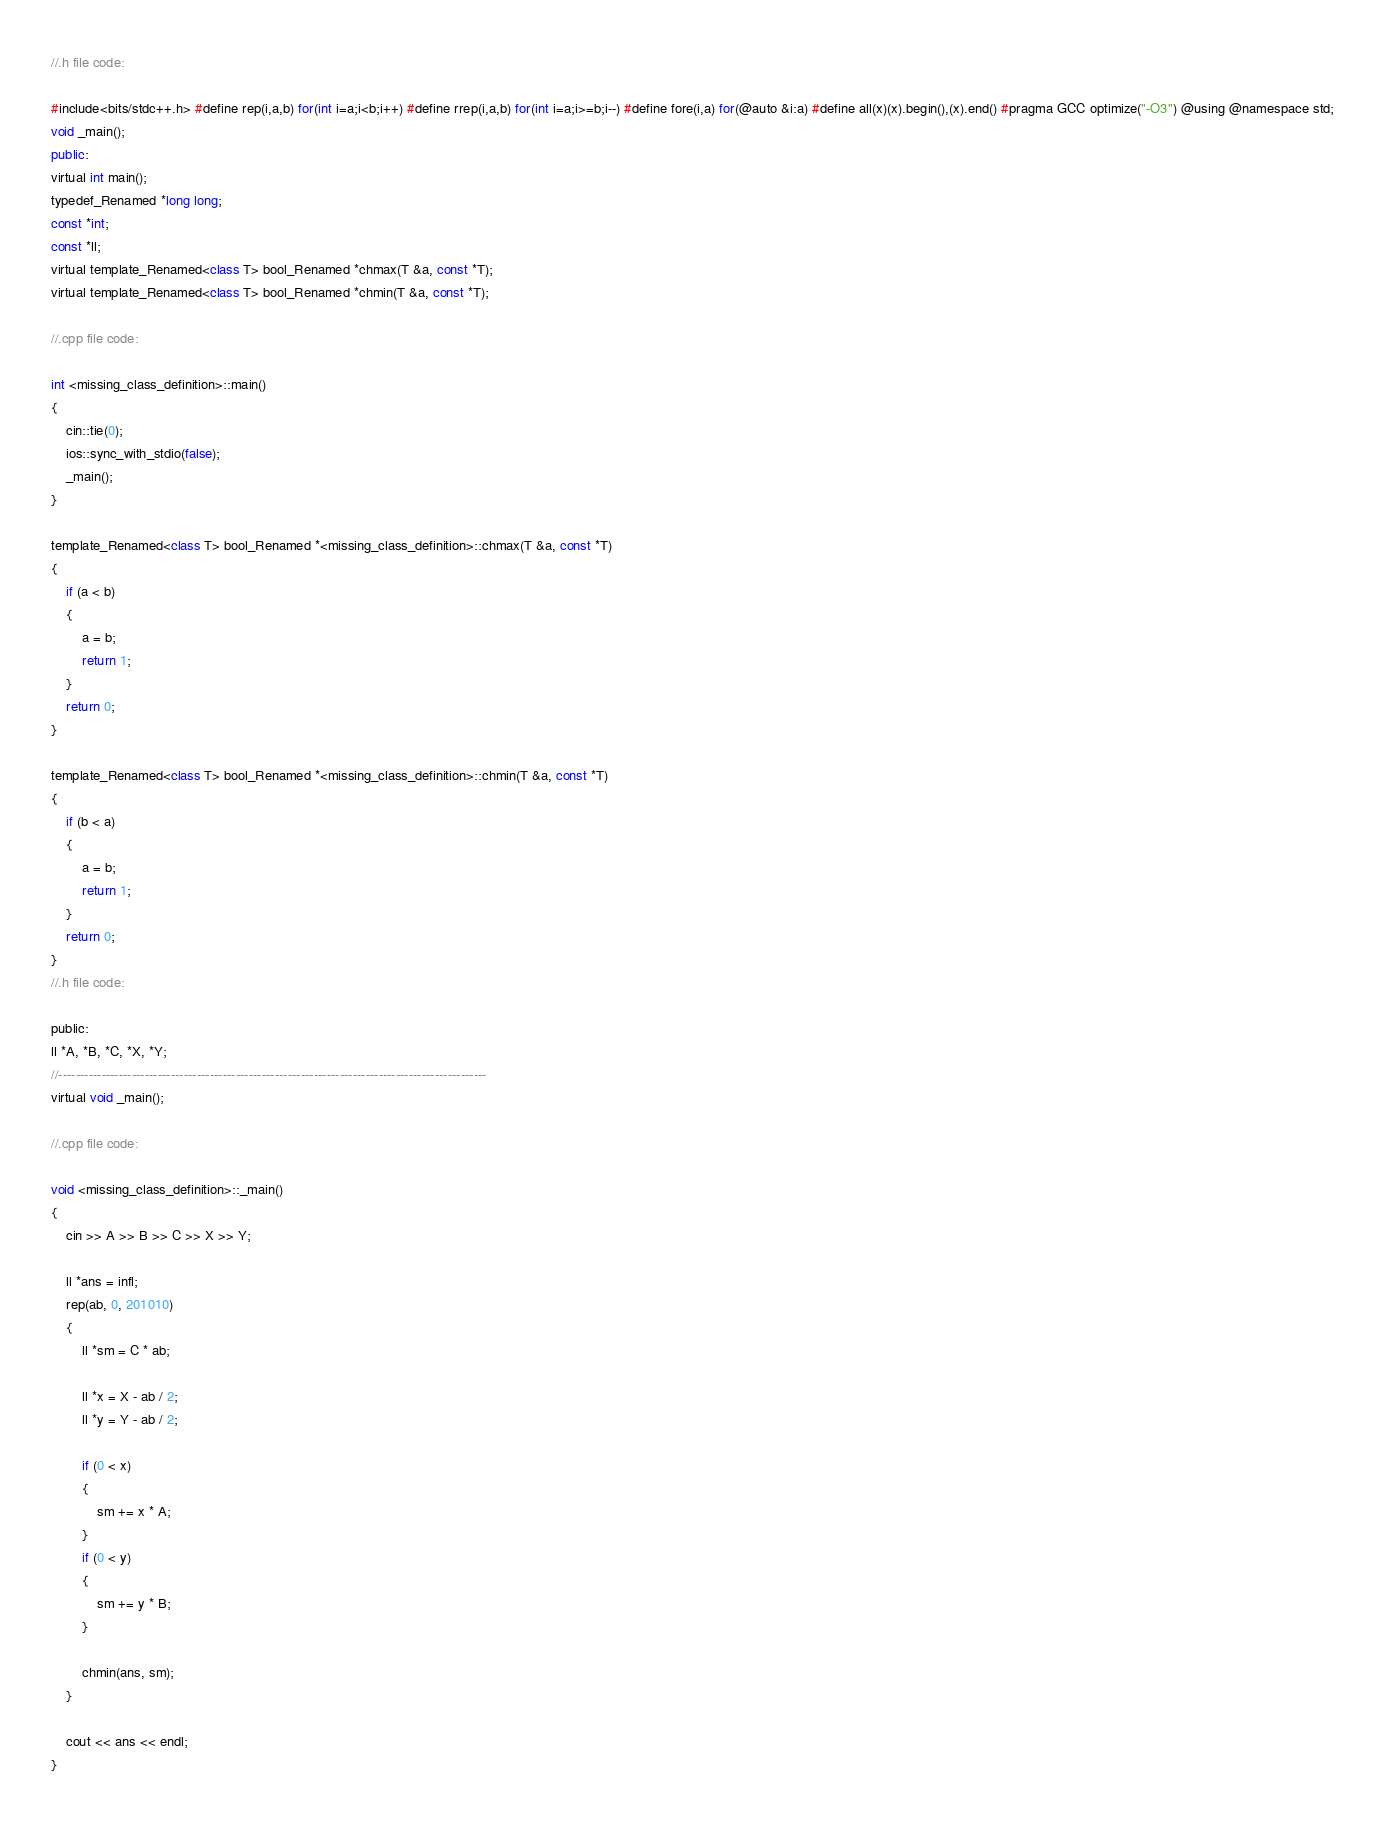Convert code to text. <code><loc_0><loc_0><loc_500><loc_500><_Java_>//.h file code:

#include<bits/stdc++.h> #define rep(i,a,b) for(int i=a;i<b;i++) #define rrep(i,a,b) for(int i=a;i>=b;i--) #define fore(i,a) for(@auto &i:a) #define all(x)(x).begin(),(x).end() #pragma GCC optimize("-O3") @using @namespace std;
void _main();
public:
virtual int main();
typedef_Renamed *long long;
const *int;
const *ll;
virtual template_Renamed<class T> bool_Renamed *chmax(T &a, const *T);
virtual template_Renamed<class T> bool_Renamed *chmin(T &a, const *T);

//.cpp file code:

int <missing_class_definition>::main()
{
	cin::tie(0);
	ios::sync_with_stdio(false);
	_main();
}

template_Renamed<class T> bool_Renamed *<missing_class_definition>::chmax(T &a, const *T)
{
	if (a < b)
	{
		a = b;
		return 1;
	}
	return 0;
}

template_Renamed<class T> bool_Renamed *<missing_class_definition>::chmin(T &a, const *T)
{
	if (b < a)
	{
		a = b;
		return 1;
	}
	return 0;
}
//.h file code:

public:
ll *A, *B, *C, *X, *Y;
//---------------------------------------------------------------------------------------------------
virtual void _main();

//.cpp file code:

void <missing_class_definition>::_main()
{
	cin >> A >> B >> C >> X >> Y;

	ll *ans = infl;
	rep(ab, 0, 201010)
	{
		ll *sm = C * ab;

		ll *x = X - ab / 2;
		ll *y = Y - ab / 2;

		if (0 < x)
		{
			sm += x * A;
		}
		if (0 < y)
		{
			sm += y * B;
		}

		chmin(ans, sm);
	}

	cout << ans << endl;
}
</code> 